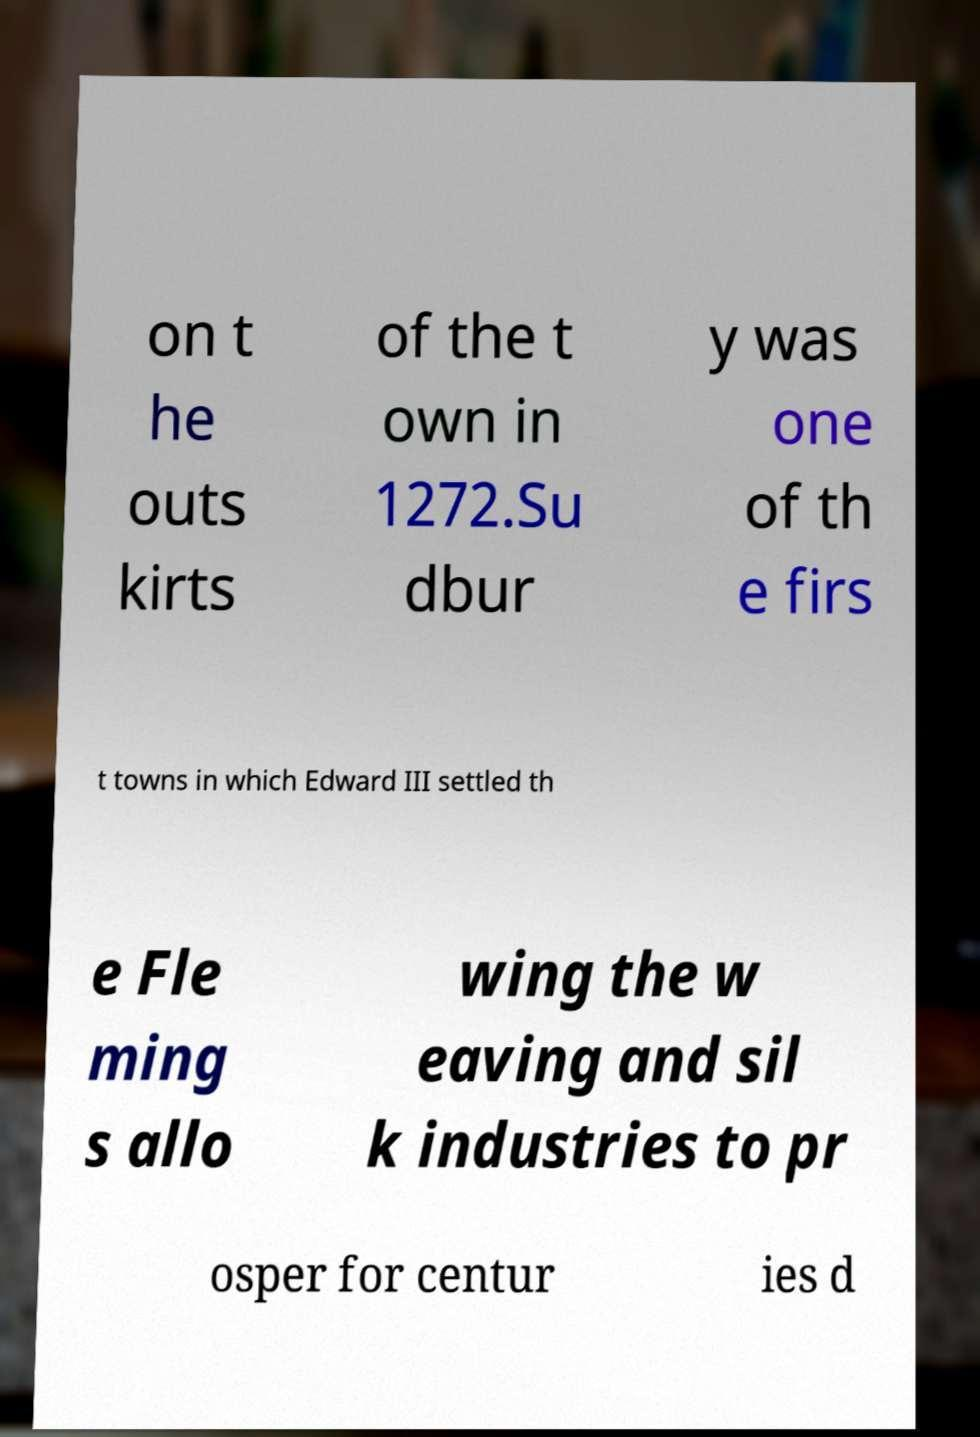Please read and relay the text visible in this image. What does it say? on t he outs kirts of the t own in 1272.Su dbur y was one of th e firs t towns in which Edward III settled th e Fle ming s allo wing the w eaving and sil k industries to pr osper for centur ies d 